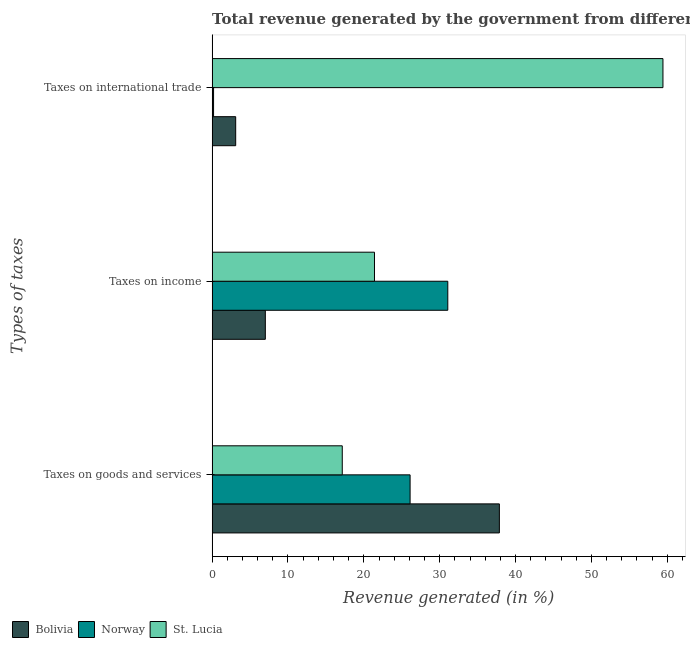How many different coloured bars are there?
Your answer should be compact. 3. Are the number of bars per tick equal to the number of legend labels?
Keep it short and to the point. Yes. Are the number of bars on each tick of the Y-axis equal?
Keep it short and to the point. Yes. What is the label of the 3rd group of bars from the top?
Ensure brevity in your answer.  Taxes on goods and services. What is the percentage of revenue generated by taxes on goods and services in Norway?
Your answer should be compact. 26.09. Across all countries, what is the maximum percentage of revenue generated by taxes on income?
Your answer should be compact. 31.06. Across all countries, what is the minimum percentage of revenue generated by taxes on goods and services?
Your answer should be very brief. 17.15. In which country was the percentage of revenue generated by taxes on goods and services maximum?
Offer a very short reply. Bolivia. In which country was the percentage of revenue generated by taxes on goods and services minimum?
Provide a short and direct response. St. Lucia. What is the total percentage of revenue generated by taxes on income in the graph?
Give a very brief answer. 59.48. What is the difference between the percentage of revenue generated by tax on international trade in Norway and that in St. Lucia?
Ensure brevity in your answer.  -59.23. What is the difference between the percentage of revenue generated by taxes on goods and services in St. Lucia and the percentage of revenue generated by taxes on income in Bolivia?
Your answer should be very brief. 10.14. What is the average percentage of revenue generated by taxes on income per country?
Ensure brevity in your answer.  19.83. What is the difference between the percentage of revenue generated by taxes on income and percentage of revenue generated by taxes on goods and services in Bolivia?
Provide a succinct answer. -30.85. In how many countries, is the percentage of revenue generated by taxes on income greater than 6 %?
Offer a very short reply. 3. What is the ratio of the percentage of revenue generated by taxes on income in Bolivia to that in St. Lucia?
Keep it short and to the point. 0.33. Is the difference between the percentage of revenue generated by tax on international trade in St. Lucia and Bolivia greater than the difference between the percentage of revenue generated by taxes on income in St. Lucia and Bolivia?
Make the answer very short. Yes. What is the difference between the highest and the second highest percentage of revenue generated by taxes on goods and services?
Your answer should be compact. 11.77. What is the difference between the highest and the lowest percentage of revenue generated by tax on international trade?
Offer a terse response. 59.23. Is the sum of the percentage of revenue generated by taxes on income in St. Lucia and Norway greater than the maximum percentage of revenue generated by tax on international trade across all countries?
Offer a terse response. No. What is the difference between two consecutive major ticks on the X-axis?
Offer a very short reply. 10. Where does the legend appear in the graph?
Provide a succinct answer. Bottom left. How are the legend labels stacked?
Ensure brevity in your answer.  Horizontal. What is the title of the graph?
Provide a succinct answer. Total revenue generated by the government from different taxes in 2004. What is the label or title of the X-axis?
Offer a very short reply. Revenue generated (in %). What is the label or title of the Y-axis?
Keep it short and to the point. Types of taxes. What is the Revenue generated (in %) of Bolivia in Taxes on goods and services?
Offer a very short reply. 37.86. What is the Revenue generated (in %) of Norway in Taxes on goods and services?
Keep it short and to the point. 26.09. What is the Revenue generated (in %) of St. Lucia in Taxes on goods and services?
Provide a short and direct response. 17.15. What is the Revenue generated (in %) in Bolivia in Taxes on income?
Provide a short and direct response. 7.01. What is the Revenue generated (in %) of Norway in Taxes on income?
Your response must be concise. 31.06. What is the Revenue generated (in %) in St. Lucia in Taxes on income?
Your response must be concise. 21.4. What is the Revenue generated (in %) in Bolivia in Taxes on international trade?
Make the answer very short. 3.11. What is the Revenue generated (in %) in Norway in Taxes on international trade?
Provide a succinct answer. 0.19. What is the Revenue generated (in %) in St. Lucia in Taxes on international trade?
Provide a short and direct response. 59.42. Across all Types of taxes, what is the maximum Revenue generated (in %) in Bolivia?
Your response must be concise. 37.86. Across all Types of taxes, what is the maximum Revenue generated (in %) of Norway?
Give a very brief answer. 31.06. Across all Types of taxes, what is the maximum Revenue generated (in %) of St. Lucia?
Give a very brief answer. 59.42. Across all Types of taxes, what is the minimum Revenue generated (in %) in Bolivia?
Keep it short and to the point. 3.11. Across all Types of taxes, what is the minimum Revenue generated (in %) of Norway?
Offer a very short reply. 0.19. Across all Types of taxes, what is the minimum Revenue generated (in %) of St. Lucia?
Provide a short and direct response. 17.15. What is the total Revenue generated (in %) in Bolivia in the graph?
Offer a very short reply. 47.98. What is the total Revenue generated (in %) of Norway in the graph?
Provide a short and direct response. 57.35. What is the total Revenue generated (in %) of St. Lucia in the graph?
Provide a short and direct response. 97.98. What is the difference between the Revenue generated (in %) of Bolivia in Taxes on goods and services and that in Taxes on income?
Keep it short and to the point. 30.85. What is the difference between the Revenue generated (in %) of Norway in Taxes on goods and services and that in Taxes on income?
Provide a succinct answer. -4.97. What is the difference between the Revenue generated (in %) of St. Lucia in Taxes on goods and services and that in Taxes on income?
Your answer should be compact. -4.25. What is the difference between the Revenue generated (in %) of Bolivia in Taxes on goods and services and that in Taxes on international trade?
Your answer should be very brief. 34.76. What is the difference between the Revenue generated (in %) in Norway in Taxes on goods and services and that in Taxes on international trade?
Make the answer very short. 25.91. What is the difference between the Revenue generated (in %) in St. Lucia in Taxes on goods and services and that in Taxes on international trade?
Offer a terse response. -42.27. What is the difference between the Revenue generated (in %) in Bolivia in Taxes on income and that in Taxes on international trade?
Keep it short and to the point. 3.91. What is the difference between the Revenue generated (in %) of Norway in Taxes on income and that in Taxes on international trade?
Offer a very short reply. 30.87. What is the difference between the Revenue generated (in %) of St. Lucia in Taxes on income and that in Taxes on international trade?
Give a very brief answer. -38.02. What is the difference between the Revenue generated (in %) of Bolivia in Taxes on goods and services and the Revenue generated (in %) of Norway in Taxes on income?
Provide a short and direct response. 6.8. What is the difference between the Revenue generated (in %) in Bolivia in Taxes on goods and services and the Revenue generated (in %) in St. Lucia in Taxes on income?
Provide a short and direct response. 16.46. What is the difference between the Revenue generated (in %) of Norway in Taxes on goods and services and the Revenue generated (in %) of St. Lucia in Taxes on income?
Offer a terse response. 4.69. What is the difference between the Revenue generated (in %) of Bolivia in Taxes on goods and services and the Revenue generated (in %) of Norway in Taxes on international trade?
Offer a very short reply. 37.67. What is the difference between the Revenue generated (in %) of Bolivia in Taxes on goods and services and the Revenue generated (in %) of St. Lucia in Taxes on international trade?
Your response must be concise. -21.56. What is the difference between the Revenue generated (in %) in Norway in Taxes on goods and services and the Revenue generated (in %) in St. Lucia in Taxes on international trade?
Keep it short and to the point. -33.33. What is the difference between the Revenue generated (in %) in Bolivia in Taxes on income and the Revenue generated (in %) in Norway in Taxes on international trade?
Give a very brief answer. 6.82. What is the difference between the Revenue generated (in %) of Bolivia in Taxes on income and the Revenue generated (in %) of St. Lucia in Taxes on international trade?
Offer a terse response. -52.41. What is the difference between the Revenue generated (in %) of Norway in Taxes on income and the Revenue generated (in %) of St. Lucia in Taxes on international trade?
Offer a very short reply. -28.36. What is the average Revenue generated (in %) in Bolivia per Types of taxes?
Give a very brief answer. 15.99. What is the average Revenue generated (in %) in Norway per Types of taxes?
Ensure brevity in your answer.  19.12. What is the average Revenue generated (in %) in St. Lucia per Types of taxes?
Offer a terse response. 32.66. What is the difference between the Revenue generated (in %) in Bolivia and Revenue generated (in %) in Norway in Taxes on goods and services?
Make the answer very short. 11.77. What is the difference between the Revenue generated (in %) of Bolivia and Revenue generated (in %) of St. Lucia in Taxes on goods and services?
Offer a terse response. 20.71. What is the difference between the Revenue generated (in %) in Norway and Revenue generated (in %) in St. Lucia in Taxes on goods and services?
Your response must be concise. 8.94. What is the difference between the Revenue generated (in %) of Bolivia and Revenue generated (in %) of Norway in Taxes on income?
Keep it short and to the point. -24.05. What is the difference between the Revenue generated (in %) of Bolivia and Revenue generated (in %) of St. Lucia in Taxes on income?
Keep it short and to the point. -14.39. What is the difference between the Revenue generated (in %) of Norway and Revenue generated (in %) of St. Lucia in Taxes on income?
Your answer should be very brief. 9.66. What is the difference between the Revenue generated (in %) of Bolivia and Revenue generated (in %) of Norway in Taxes on international trade?
Offer a very short reply. 2.92. What is the difference between the Revenue generated (in %) of Bolivia and Revenue generated (in %) of St. Lucia in Taxes on international trade?
Provide a succinct answer. -56.32. What is the difference between the Revenue generated (in %) in Norway and Revenue generated (in %) in St. Lucia in Taxes on international trade?
Your answer should be very brief. -59.23. What is the ratio of the Revenue generated (in %) of Bolivia in Taxes on goods and services to that in Taxes on income?
Give a very brief answer. 5.4. What is the ratio of the Revenue generated (in %) in Norway in Taxes on goods and services to that in Taxes on income?
Your response must be concise. 0.84. What is the ratio of the Revenue generated (in %) in St. Lucia in Taxes on goods and services to that in Taxes on income?
Offer a terse response. 0.8. What is the ratio of the Revenue generated (in %) in Bolivia in Taxes on goods and services to that in Taxes on international trade?
Your answer should be very brief. 12.19. What is the ratio of the Revenue generated (in %) in Norway in Taxes on goods and services to that in Taxes on international trade?
Your answer should be very brief. 138.11. What is the ratio of the Revenue generated (in %) of St. Lucia in Taxes on goods and services to that in Taxes on international trade?
Give a very brief answer. 0.29. What is the ratio of the Revenue generated (in %) of Bolivia in Taxes on income to that in Taxes on international trade?
Make the answer very short. 2.26. What is the ratio of the Revenue generated (in %) of Norway in Taxes on income to that in Taxes on international trade?
Your response must be concise. 164.4. What is the ratio of the Revenue generated (in %) in St. Lucia in Taxes on income to that in Taxes on international trade?
Your answer should be very brief. 0.36. What is the difference between the highest and the second highest Revenue generated (in %) of Bolivia?
Make the answer very short. 30.85. What is the difference between the highest and the second highest Revenue generated (in %) of Norway?
Give a very brief answer. 4.97. What is the difference between the highest and the second highest Revenue generated (in %) of St. Lucia?
Provide a succinct answer. 38.02. What is the difference between the highest and the lowest Revenue generated (in %) of Bolivia?
Keep it short and to the point. 34.76. What is the difference between the highest and the lowest Revenue generated (in %) in Norway?
Your response must be concise. 30.87. What is the difference between the highest and the lowest Revenue generated (in %) of St. Lucia?
Give a very brief answer. 42.27. 